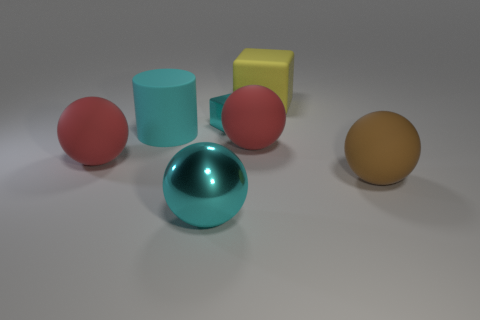Subtract all big cyan metal spheres. How many spheres are left? 3 Add 2 tiny shiny cubes. How many objects exist? 9 Subtract all balls. How many objects are left? 3 Subtract all purple blocks. How many red balls are left? 2 Subtract all brown balls. How many balls are left? 3 Add 6 cyan metal cubes. How many cyan metal cubes are left? 7 Add 6 cyan rubber cylinders. How many cyan rubber cylinders exist? 7 Subtract 0 blue cubes. How many objects are left? 7 Subtract 1 cubes. How many cubes are left? 1 Subtract all purple balls. Subtract all cyan blocks. How many balls are left? 4 